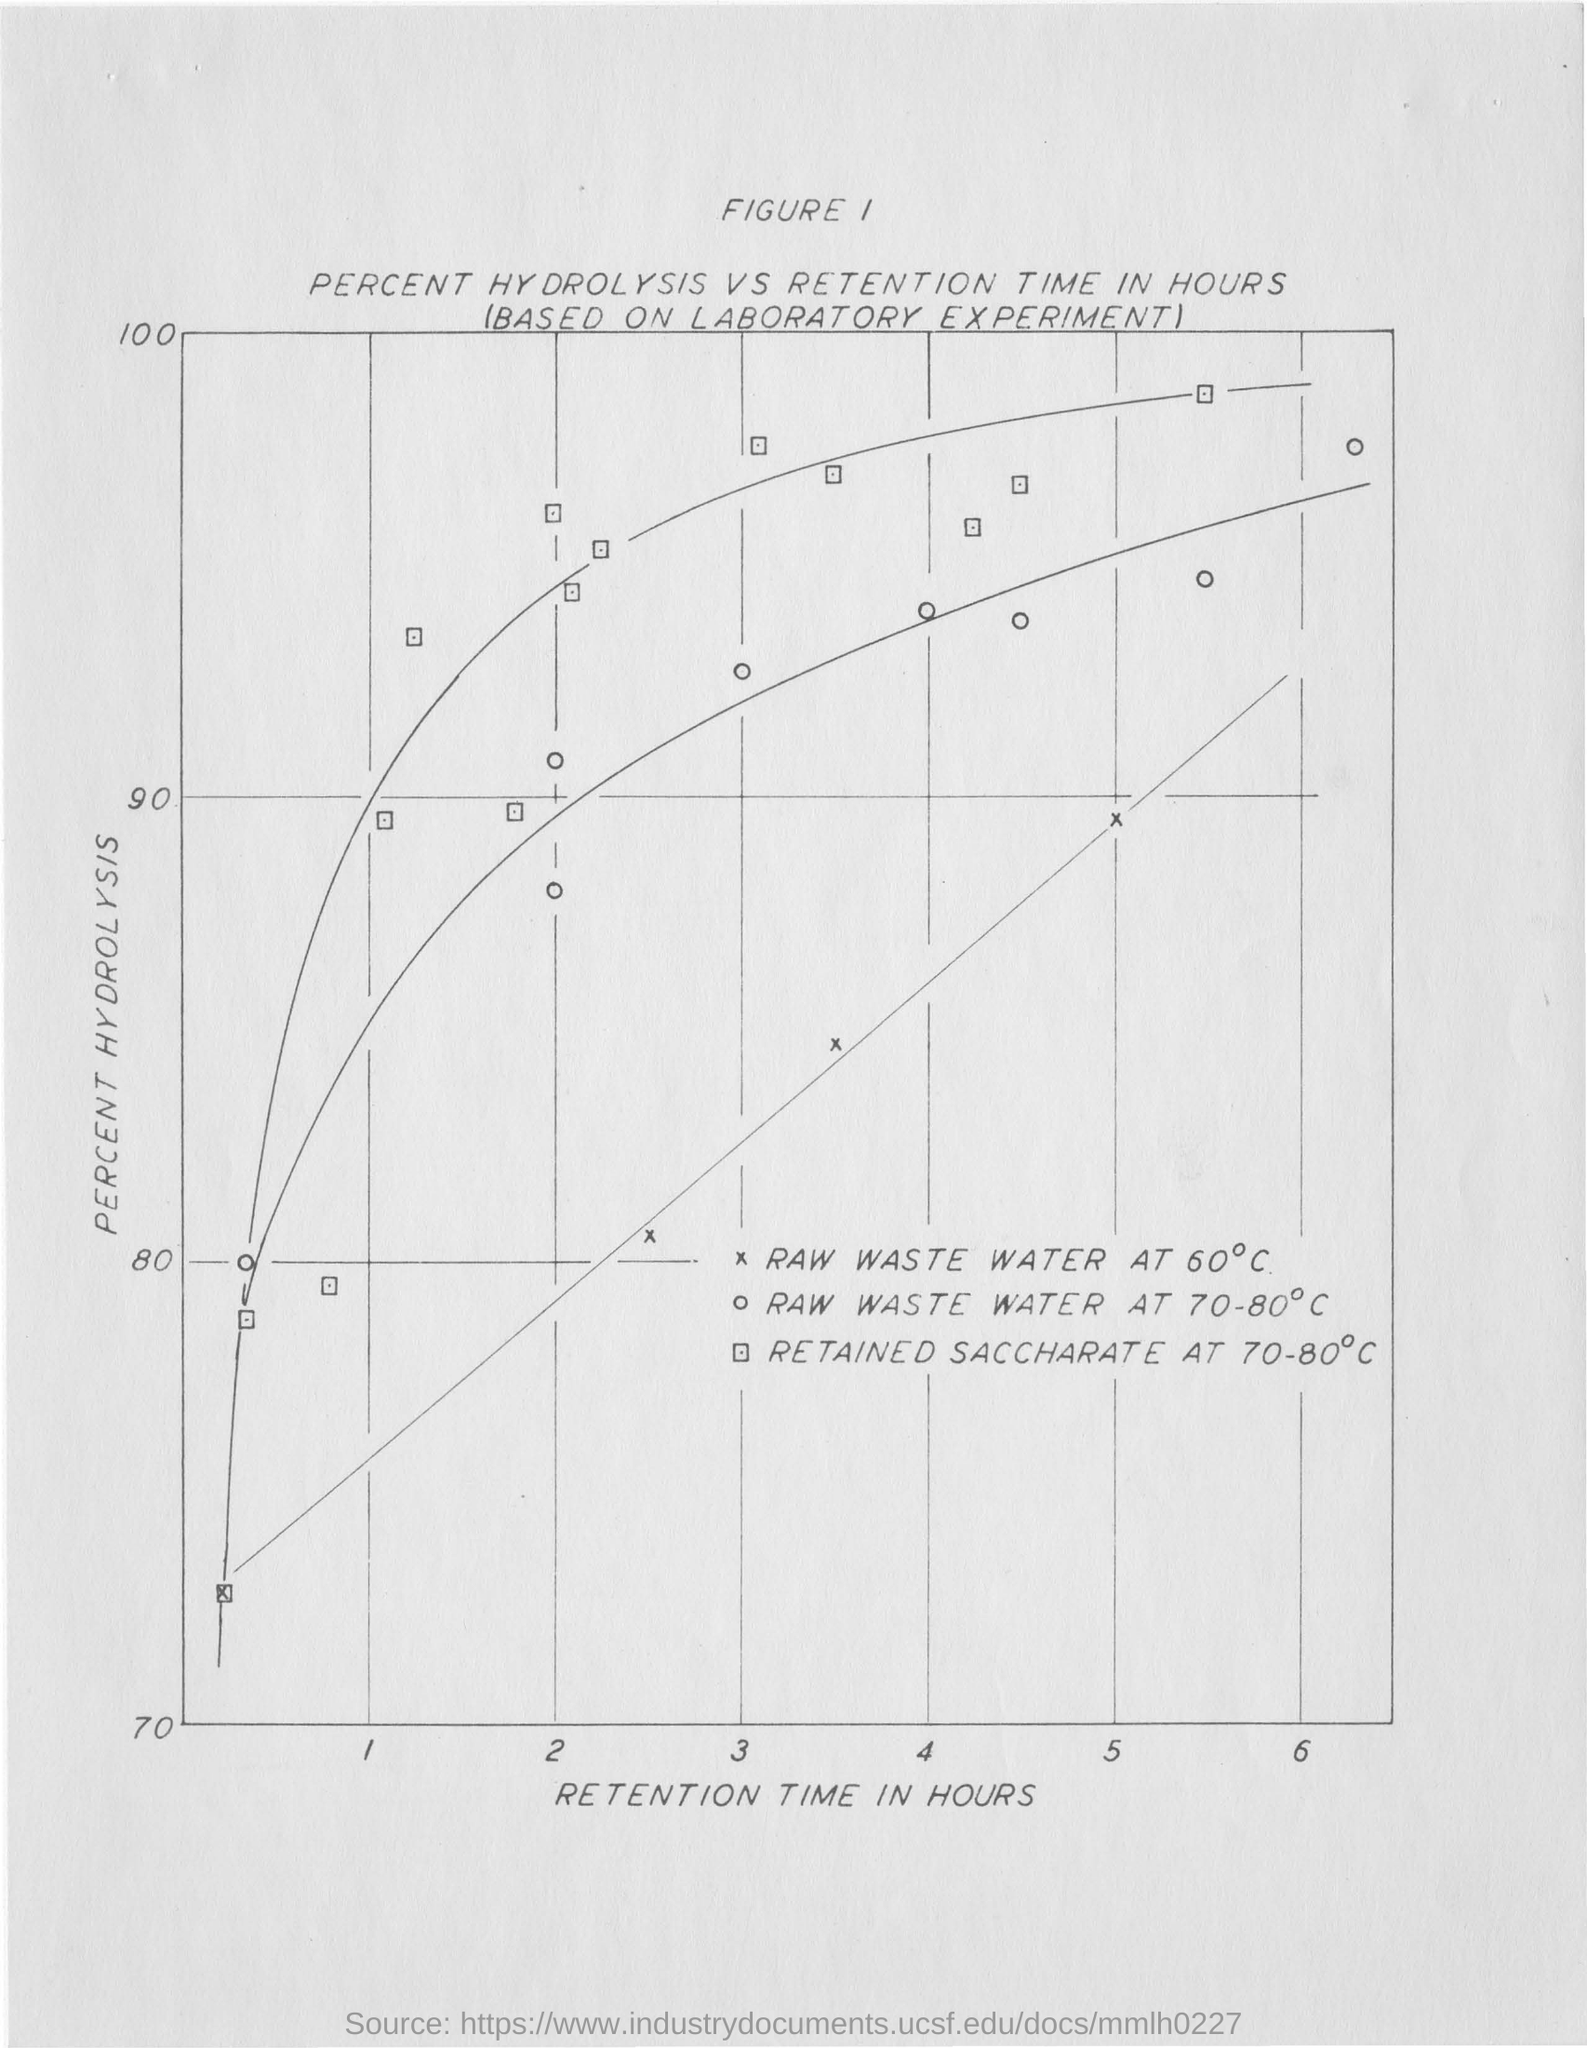What is the parameter given in x-axis of the graph?
Your answer should be very brief. Retention time in hours. What is the parameter given in y-axis of the graph?
Offer a very short reply. Percent Hydrolysis. What does the graph represents?
Keep it short and to the point. Percent hydrolysis vs retention time in hours. 